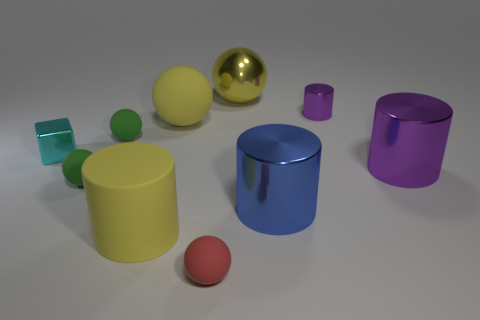What can you infer about the lighting in this scene based on the shadows and reflections? The lighting in the scene seems to be coming from above as indicated by the positioning of the shadows cast by the objects. The soft-edged shadows suggest a diffused light source, creating a subtle and evenly lit environment. The reflections on the glossy surfaces further imply a single, bright light source. 